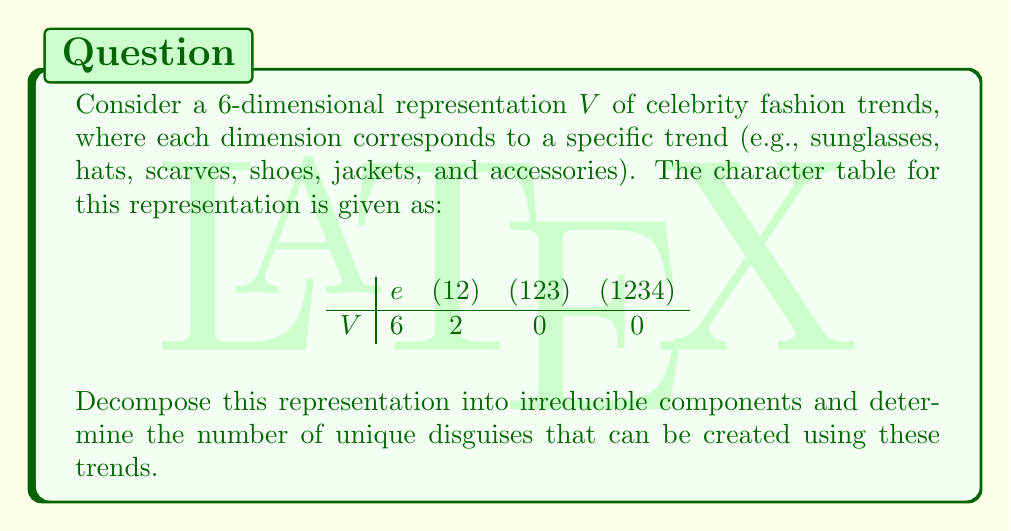Show me your answer to this math problem. To decompose the representation $V$ into irreducible components, we'll follow these steps:

1) First, recall that for the symmetric group $S_4$, there are 5 irreducible representations: the trivial representation (1), the sign representation ($\epsilon$), the standard representation (3), and two other representations (2) and (3').

2) The character table for $S_4$ is:

$$\begin{array}{c|cccc}
 & e & (12) & (123) & (1234) \\
\hline
1 & 1 & 1 & 1 & 1 \\
\epsilon & 1 & -1 & 1 & -1 \\
3 & 3 & 1 & 0 & -1 \\
2 & 2 & 0 & -1 & 0 \\
3' & 3 & -1 & 0 & 1
\end{array}$$

3) To find the decomposition, we need to calculate the inner product of $V$ with each irreducible representation. The formula is:

   $\langle V, W \rangle = \frac{1}{|G|} \sum_{g \in G} \chi_V(g) \overline{\chi_W(g)}$

   where $\chi_V$ and $\chi_W$ are the characters of $V$ and $W$ respectively.

4) Calculating for each irreducible representation:

   $\langle V, 1 \rangle = \frac{1}{24}(6 \cdot 1 + 6 \cdot 1 + 8 \cdot 0 + 6 \cdot 0) = \frac{1}{2} = 0.5$
   
   $\langle V, \epsilon \rangle = \frac{1}{24}(6 \cdot 1 + 6 \cdot (-1) + 8 \cdot 0 + 6 \cdot 0) = 0$
   
   $\langle V, 3 \rangle = \frac{1}{24}(6 \cdot 3 + 6 \cdot 1 + 8 \cdot 0 + 6 \cdot (-1)) = 1$
   
   $\langle V, 2 \rangle = \frac{1}{24}(6 \cdot 2 + 6 \cdot 0 + 8 \cdot (-1) + 6 \cdot 0) = \frac{1}{2} = 0.5$
   
   $\langle V, 3' \rangle = \frac{1}{24}(6 \cdot 3 + 6 \cdot (-1) + 8 \cdot 0 + 6 \cdot 1) = 1$

5) Rounding to the nearest integer, we get:

   $V \cong 1 \oplus 3 \oplus 3'$

6) This means we have 1 trivial representation, 1 standard representation, and 1 of the other 3-dimensional representation.

7) The number of unique disguises is the product of the dimensions of these irreducible components:

   $1 \cdot 3 \cdot 3 = 9$
Answer: $V \cong 1 \oplus 3 \oplus 3'$; 9 unique disguises 